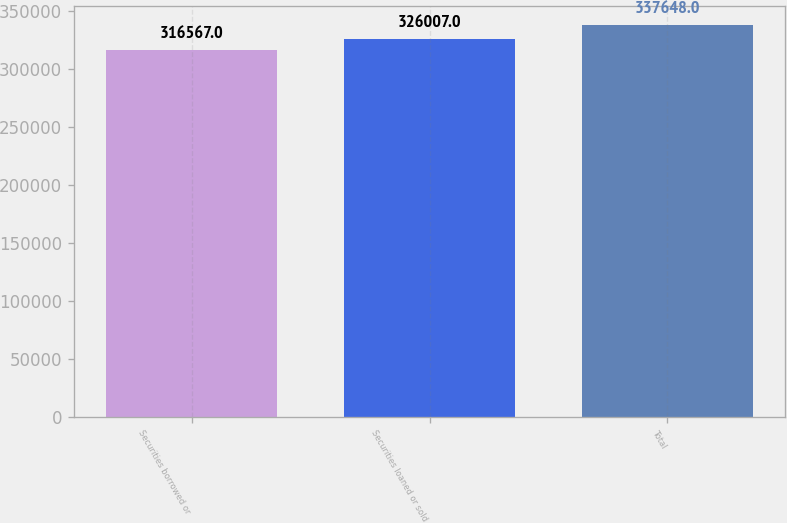Convert chart to OTSL. <chart><loc_0><loc_0><loc_500><loc_500><bar_chart><fcel>Securities borrowed or<fcel>Securities loaned or sold<fcel>Total<nl><fcel>316567<fcel>326007<fcel>337648<nl></chart> 